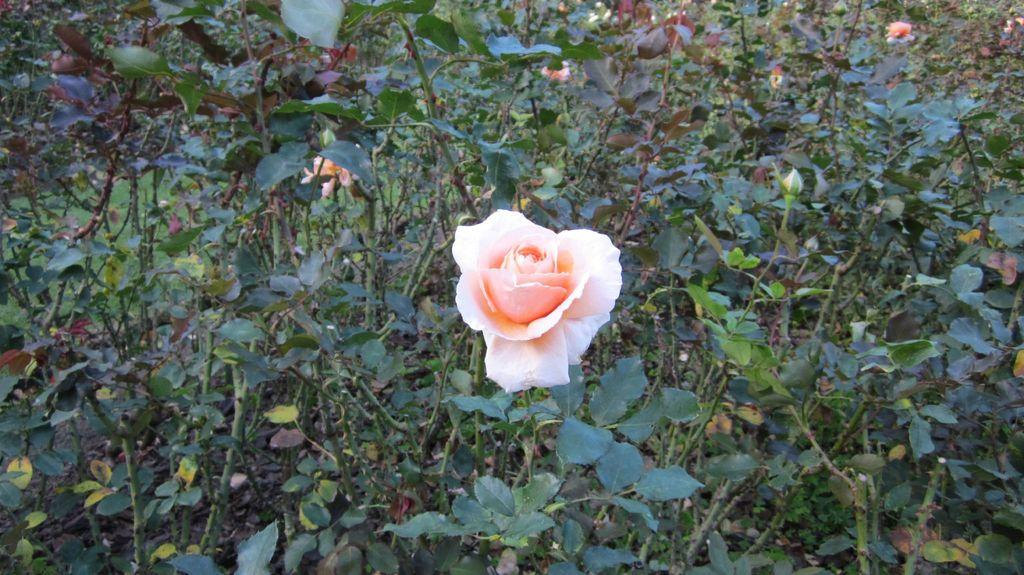What type of living organisms are present in the image? There are plants in the image. What specific feature can be observed on the plants? The plants have flowers. Where are the plants located in the image? The plants are on the ground. What type of curtain can be seen hanging from the flowers in the image? There is no curtain present in the image; the plants have flowers, but they are not associated with any curtains. 